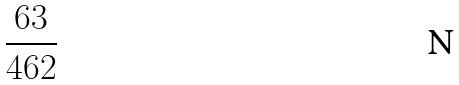Convert formula to latex. <formula><loc_0><loc_0><loc_500><loc_500>\frac { 6 3 } { 4 6 2 }</formula> 